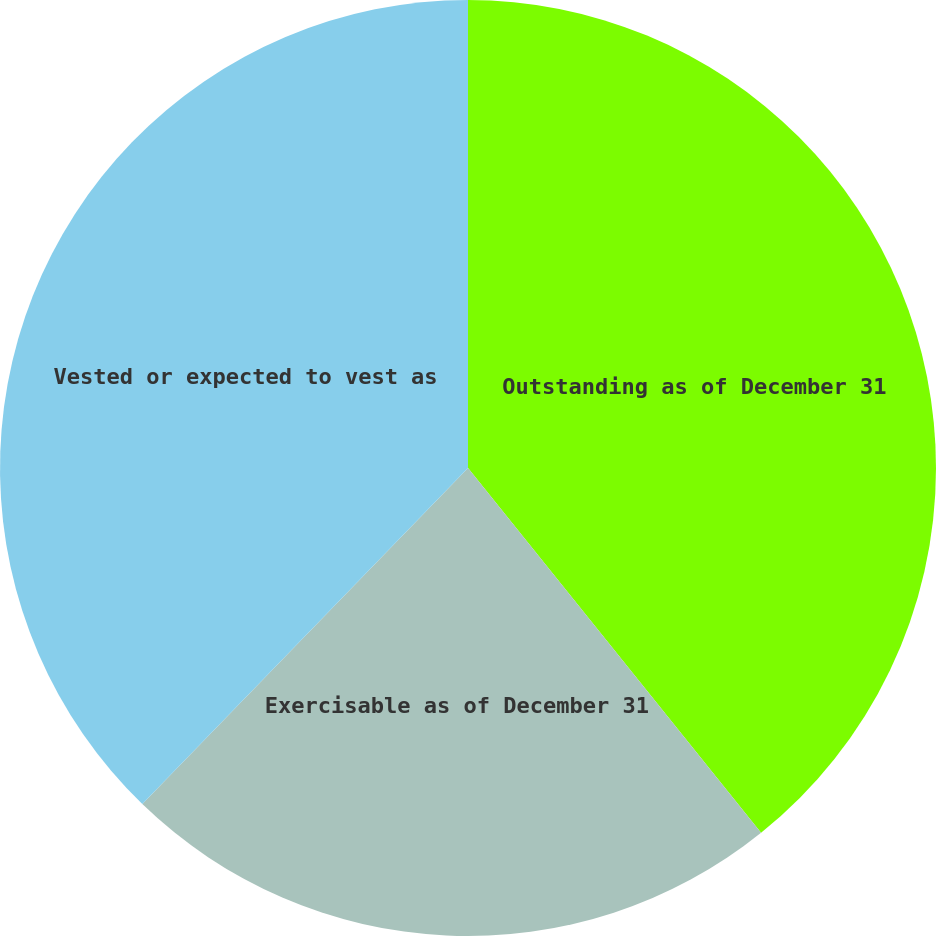Convert chart to OTSL. <chart><loc_0><loc_0><loc_500><loc_500><pie_chart><fcel>Outstanding as of December 31<fcel>Exercisable as of December 31<fcel>Vested or expected to vest as<nl><fcel>39.23%<fcel>23.02%<fcel>37.75%<nl></chart> 